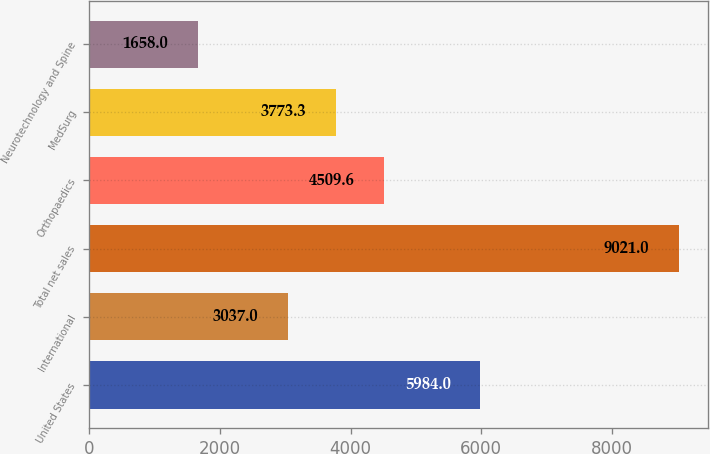Convert chart. <chart><loc_0><loc_0><loc_500><loc_500><bar_chart><fcel>United States<fcel>International<fcel>Total net sales<fcel>Orthopaedics<fcel>MedSurg<fcel>Neurotechnology and Spine<nl><fcel>5984<fcel>3037<fcel>9021<fcel>4509.6<fcel>3773.3<fcel>1658<nl></chart> 